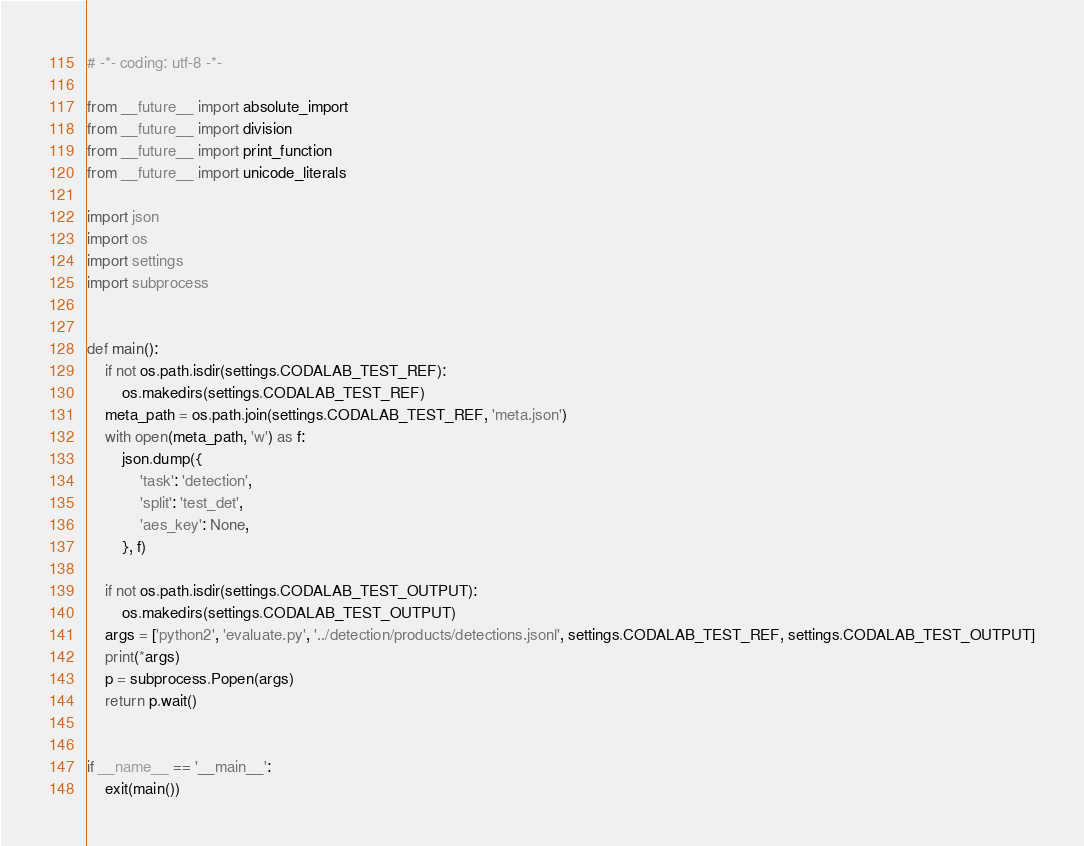<code> <loc_0><loc_0><loc_500><loc_500><_Python_># -*- coding: utf-8 -*-

from __future__ import absolute_import
from __future__ import division
from __future__ import print_function
from __future__ import unicode_literals

import json
import os
import settings
import subprocess


def main():
    if not os.path.isdir(settings.CODALAB_TEST_REF):
        os.makedirs(settings.CODALAB_TEST_REF)
    meta_path = os.path.join(settings.CODALAB_TEST_REF, 'meta.json')
    with open(meta_path, 'w') as f:
        json.dump({
            'task': 'detection',
            'split': 'test_det',
            'aes_key': None,
        }, f)

    if not os.path.isdir(settings.CODALAB_TEST_OUTPUT):
        os.makedirs(settings.CODALAB_TEST_OUTPUT)
    args = ['python2', 'evaluate.py', '../detection/products/detections.jsonl', settings.CODALAB_TEST_REF, settings.CODALAB_TEST_OUTPUT]
    print(*args)
    p = subprocess.Popen(args)
    return p.wait()


if __name__ == '__main__':
    exit(main())
</code> 